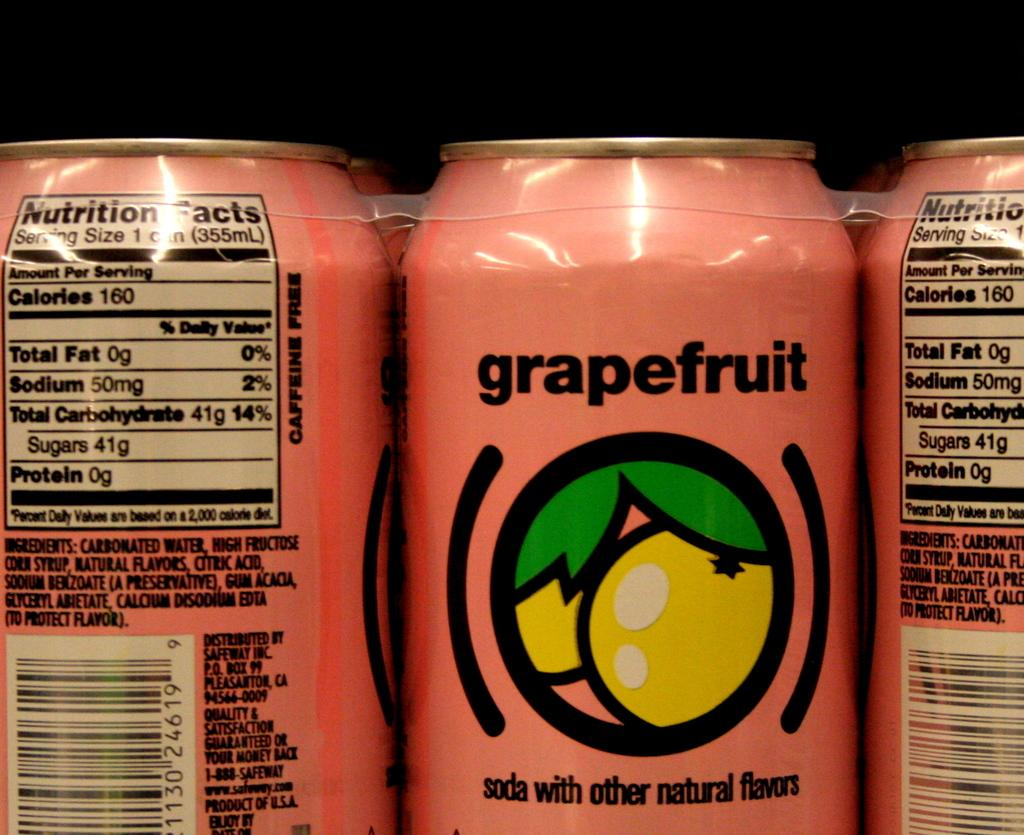<image>
Give a short and clear explanation of the subsequent image. A six pack of pink cans labeled grapefruit, each of which contains 160 calories. 